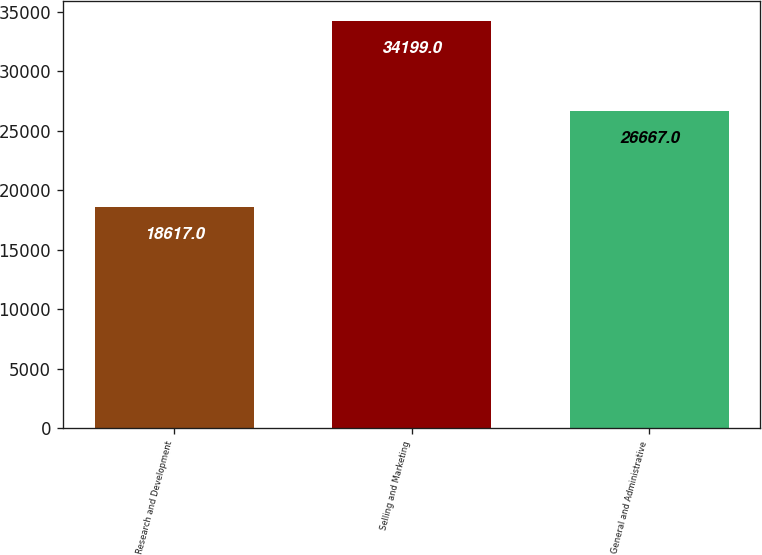Convert chart to OTSL. <chart><loc_0><loc_0><loc_500><loc_500><bar_chart><fcel>Research and Development<fcel>Selling and Marketing<fcel>General and Administrative<nl><fcel>18617<fcel>34199<fcel>26667<nl></chart> 